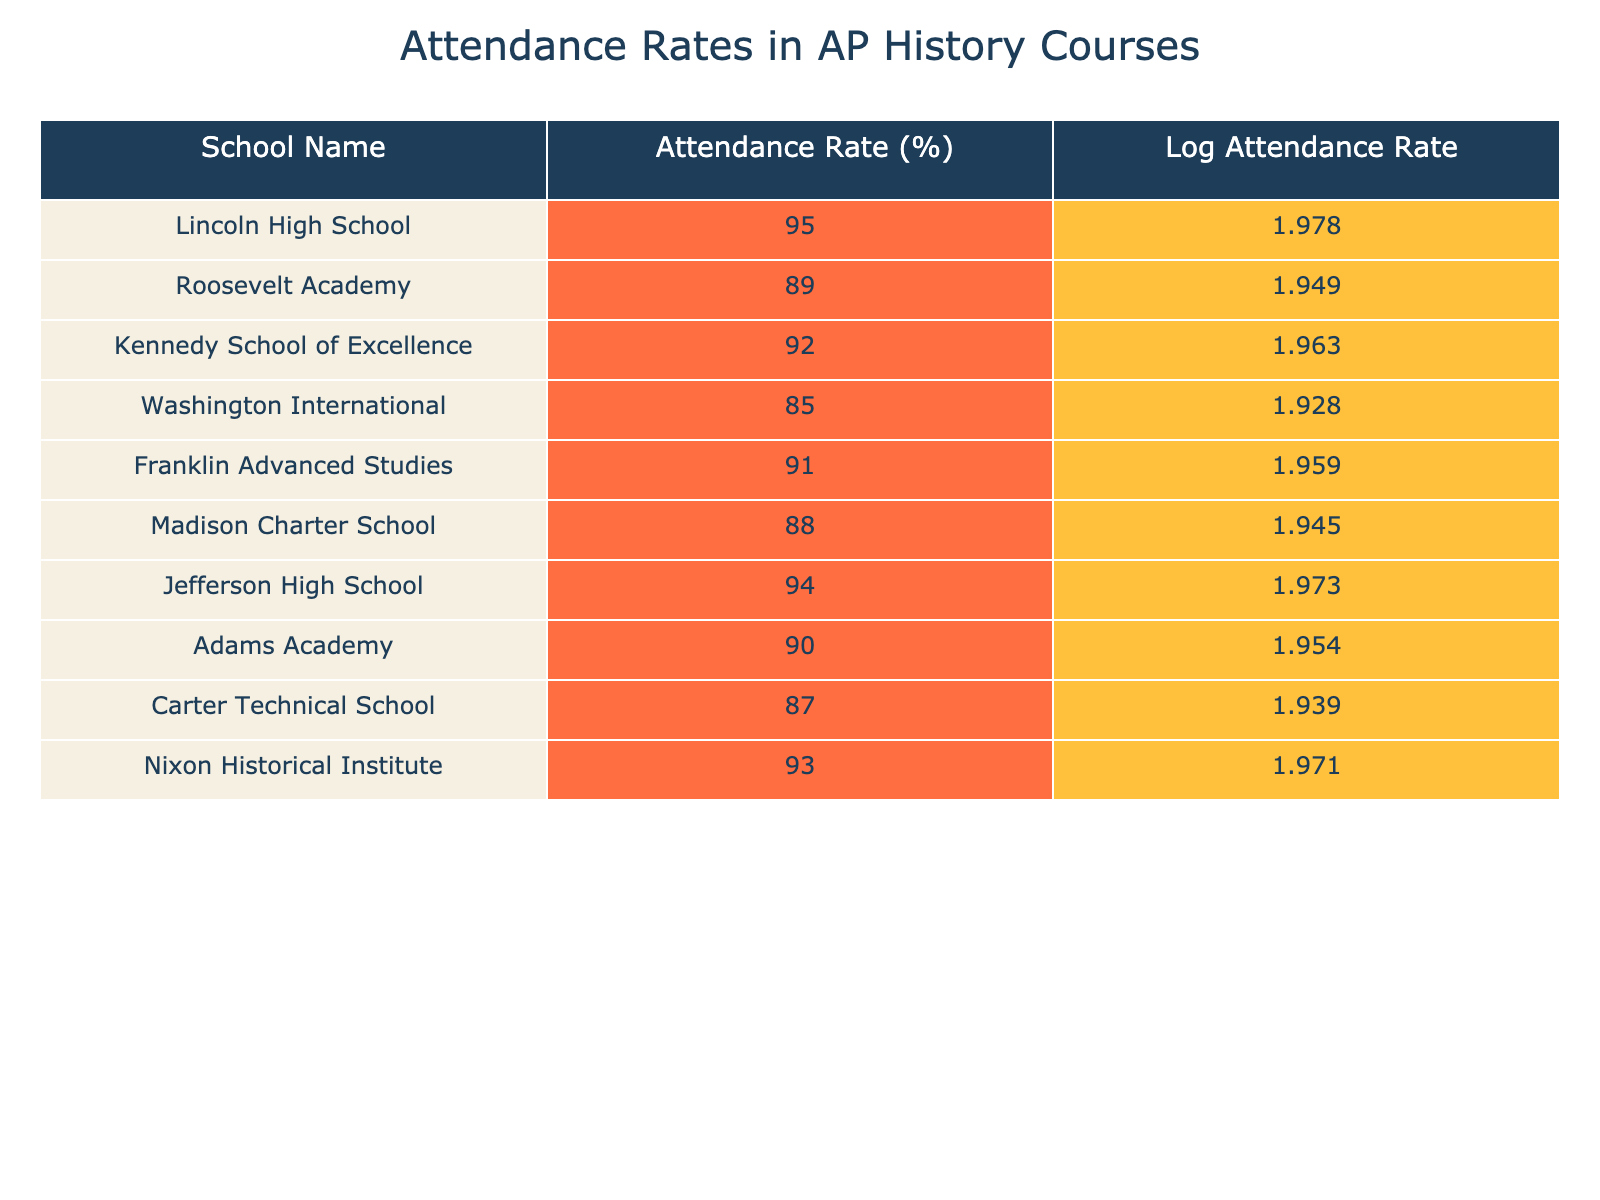What is the attendance rate of Kennedy School of Excellence? The table shows the attendance rate for each school. Looking at the row for Kennedy School of Excellence, the attendance rate listed is 92%.
Answer: 92% Which school has the highest attendance rate? By comparing the attendance rates in the table, Lincoln High School has the highest attendance rate at 95%.
Answer: Lincoln High School What is the average attendance rate of the schools listed? To find the average, sum all the attendance rates: 95 + 89 + 92 + 85 + 91 + 88 + 94 + 90 + 87 + 93 = 909. There are 10 schools, so the average is 909/10 = 90.9%.
Answer: 90.9% Is the attendance rate of Carter Technical School greater than that of Madison Charter School? The attendance rate for Carter Technical School is 87% and for Madison Charter School is 88%. Since 87% is less than 88%, the statement is false.
Answer: No Which school has an attendance rate that is less than 90%? By looking through the attendance rates in the table, the schools with attendance rates below 90% are Roosevelt Academy (89%), Washington International (85%), Madison Charter School (88%), and Carter Technical School (87%).
Answer: Roosevelt Academy, Washington International, Madison Charter School, Carter Technical School What is the difference in attendance rates between Lincoln High School and Jefferson High School? Lincoln High School has an attendance rate of 95% and Jefferson High School has 94%. The difference is calculated as 95% - 94% = 1%.
Answer: 1% How many schools have an attendance rate above 90%? Checking the attendance rates in the table, the schools with attendance rates above 90% are Lincoln High School (95%), Kennedy School of Excellence (92%), Franklin Advanced Studies (91%), and Jefferson High School (94%). This totals to 4 schools.
Answer: 4 What is the log attendance rate of the school with the second lowest attendance rate? The school with the second lowest attendance rate is Carter Technical School at 87%. Looking at the table, the log attendance rate for Carter Technical School is 1.939.
Answer: 1.939 If the attendance rate of Washington International increased by 5%, what would its new attendance rate be? Washington International's current attendance rate is 85%. Adding 5% results in: 85% + 5% = 90%. Therefore, its new attendance rate would be 90%.
Answer: 90% 